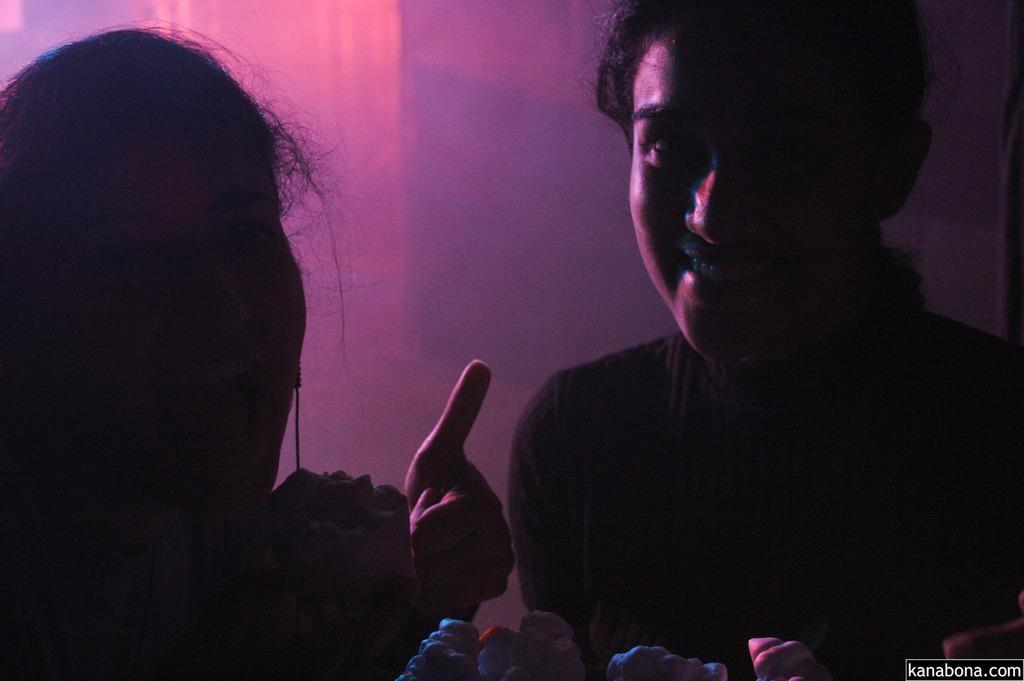Please provide a concise description of this image. In the foreground of this picture we can see the two people seems to be smiling and we can see some objects. In the background there is an object which seems to be the wall. In the bottom right corner we can see the watermark on the image. 